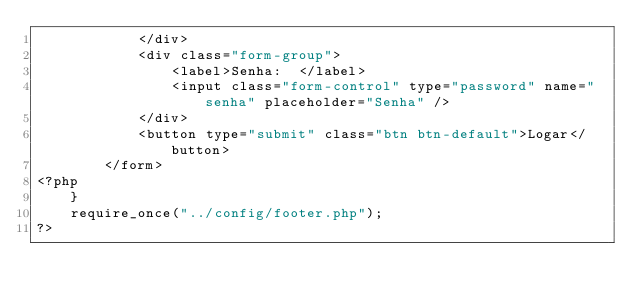<code> <loc_0><loc_0><loc_500><loc_500><_PHP_>            </div>
            <div class="form-group">
                <label>Senha:  </label>
                <input class="form-control" type="password" name="senha" placeholder="Senha" />
            </div>
            <button type="submit" class="btn btn-default">Logar</button>
        </form>
<?php
    }
    require_once("../config/footer.php");
?>
</code> 